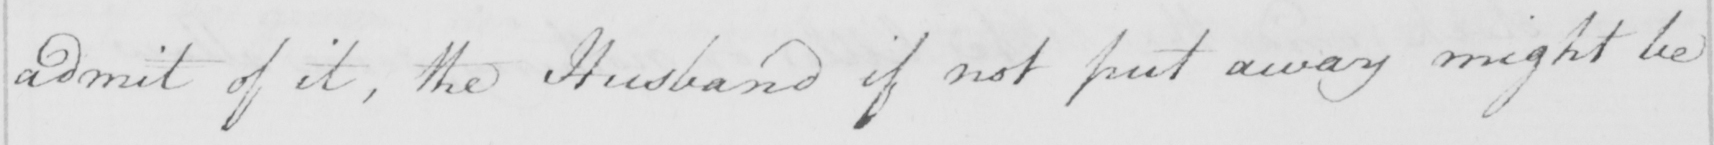Please transcribe the handwritten text in this image. admit of it , the Husband ifnot put away might be 